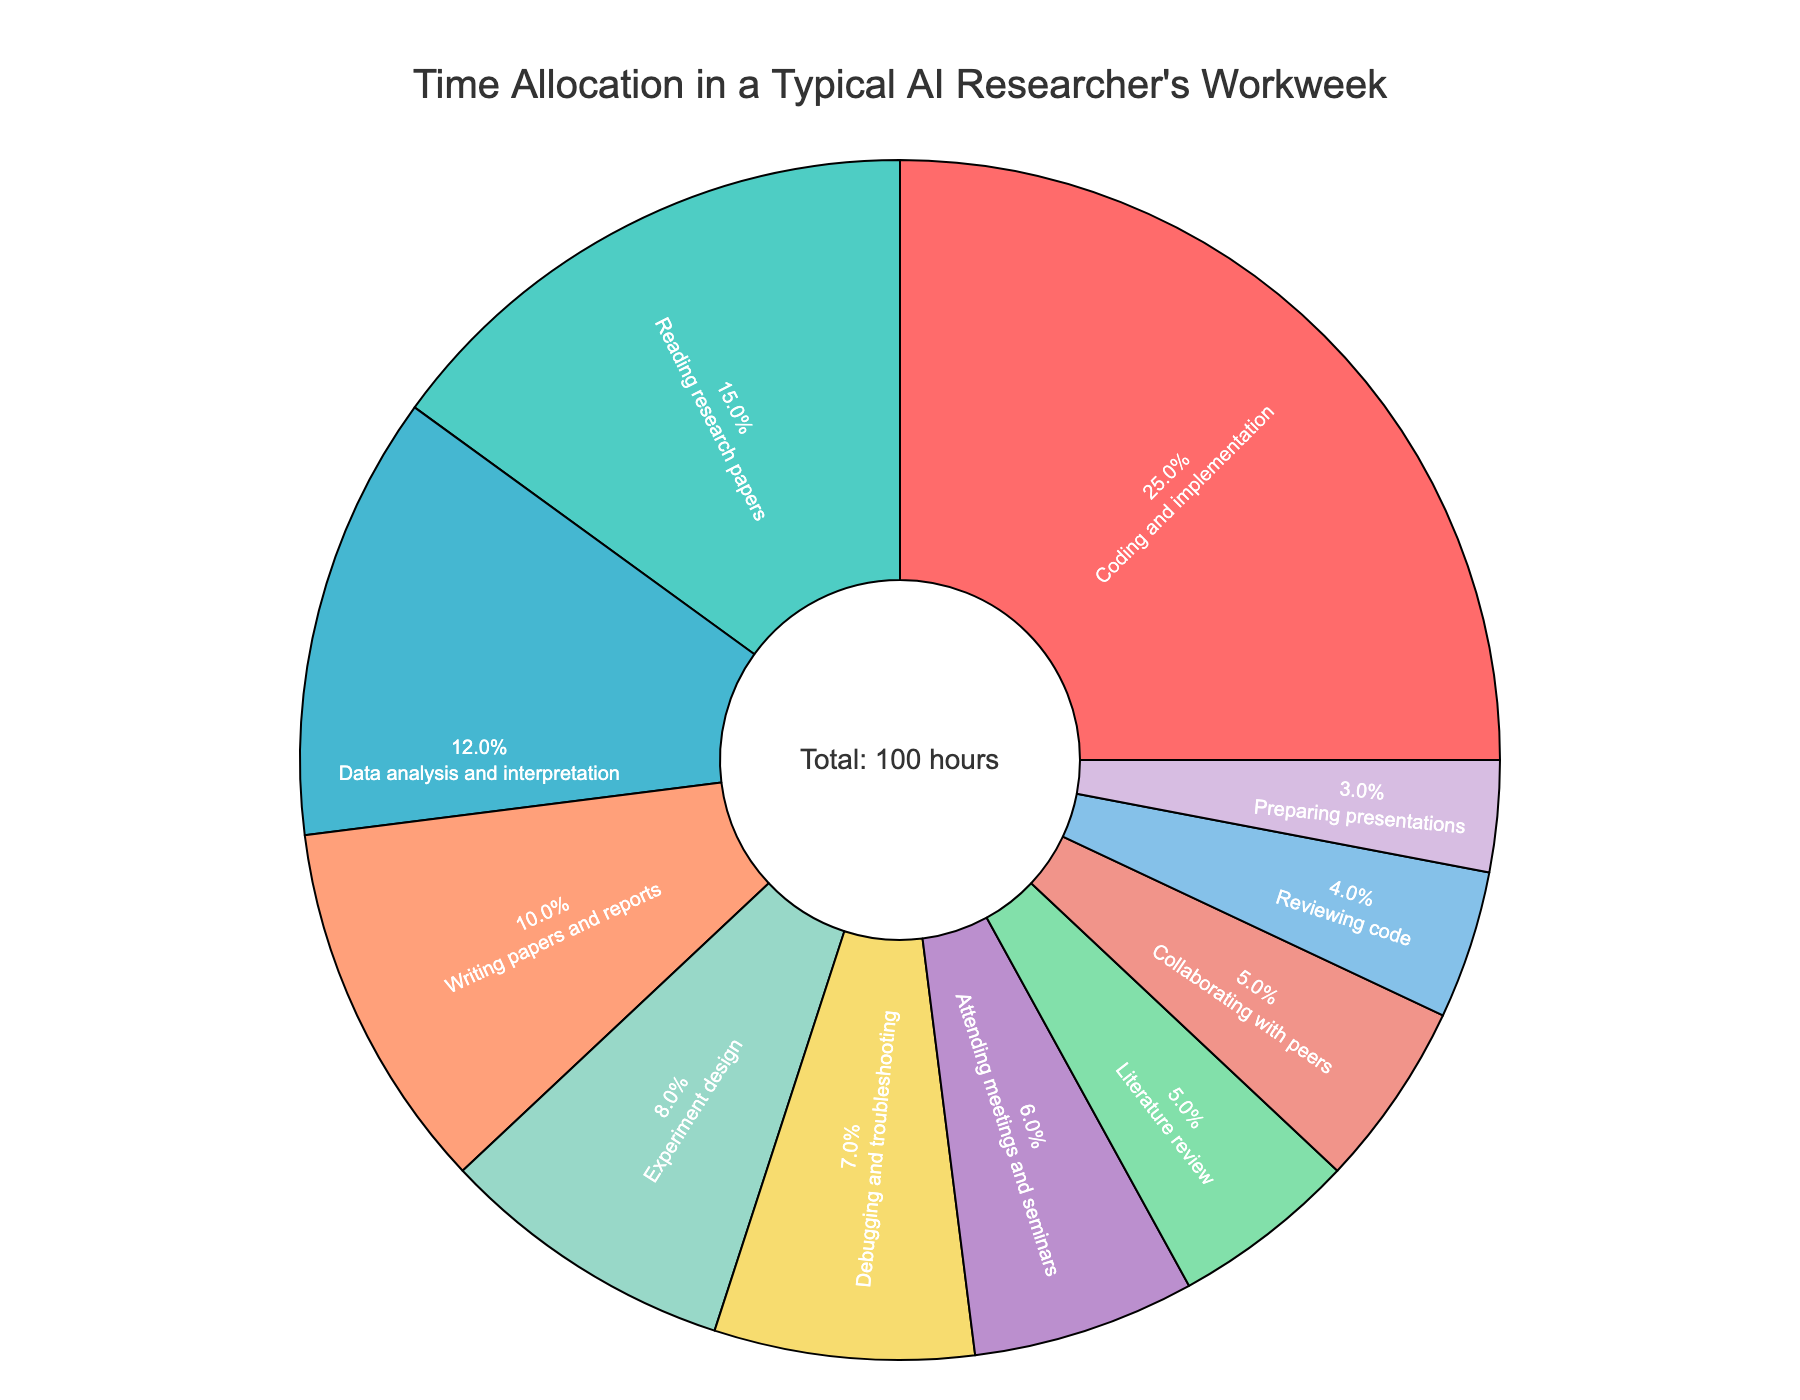How many tasks take up more than 10 hours per week? Look at the pie chart and identify the tasks that individually have more than 10 hours. Sum these tasks: "Coding and implementation" (25 hours) and "Reading research papers" (15 hours).
Answer: 2 Which task occupies the largest portion of the workweek? Refer to the largest section of the pie chart, which is prominently visible. The task labeled as "Coding and implementation" has the largest portion.
Answer: Coding and implementation Compare the time spent on collaborating with peers and reviewing code. Which one is higher? Find the sections for "Collaborating with peers" (5 hours) and "Reviewing code" (4 hours) on the pie chart. "Collaborating with peers" is higher.
Answer: Collaborating with peers How many hours are spent on both preparing presentations and attending meetings and seminars combined? Look at the sections for "Preparing presentations" (3 hours) and "Attending meetings and seminars" (6 hours). Add them together: 3 + 6 = 9 hours.
Answer: 9 Which activity has the smallest slice in the pie chart? Locate the smallest section in the pie chart. It corresponds to "Preparing presentations," which is 3 hours.
Answer: Preparing presentations Is the time spent debugging and troubleshooting greater than writing papers and reports? Compare the two sections for "Debugging and troubleshooting" (7 hours) and "Writing papers and reports" (10 hours). "Writing papers and reports" is greater.
Answer: No What is the total percentage of time spent on Experiment design and Literature review together? Identify the sections for "Experiment design" (8 hours) and "Literature review" (5 hours). Sum the hours: 8 + 5 = 13 hours. Divide by the total hours (100) and convert to percentage: 13%.
Answer: 13% How does the time spent on data analysis and interpretation compare to attending meetings and seminars? Compare the sections for "Data analysis and interpretation" (12 hours) and "Attending meetings and seminars" (6 hours). Data analysis and interpretation is higher.
Answer: Greater Which task's section is shaded in blue, and how many hours does it represent? Find the section colored in blue on the pie chart. This corresponds to "Reading research papers," which represents 15 hours.
Answer: Reading research papers, 15 hours Combine the hours spent on Literature review, Collaborating with peers, and Reviewing code. What is the total? Sum the hours for "Literature review" (5 hours), "Collaborating with peers" (5 hours), and "Reviewing code" (4 hours). The total is 5 + 5 + 4 = 14 hours.
Answer: 14 